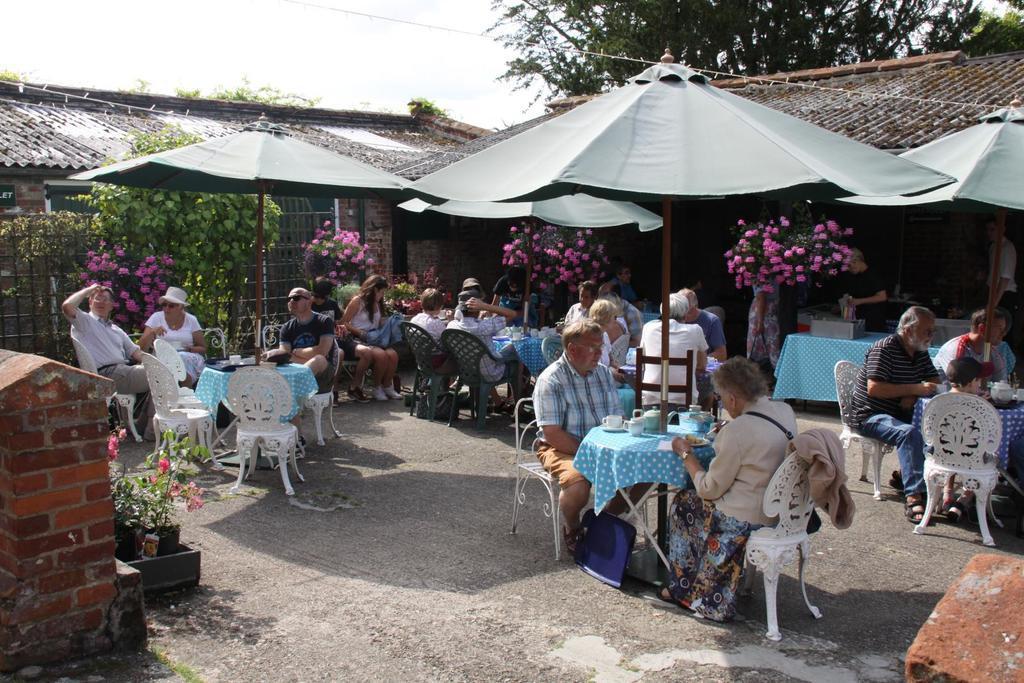Can you describe this image briefly? In this picture there are group of people sitting on the chairs and there are tables and there are cups on the tables and there are umbrellas. At the back there is a building and there are trees and flowers and there is a person standing and holding the object. In the foreground there is a wall. At the top there is sky. At the bottom there is a floor. 